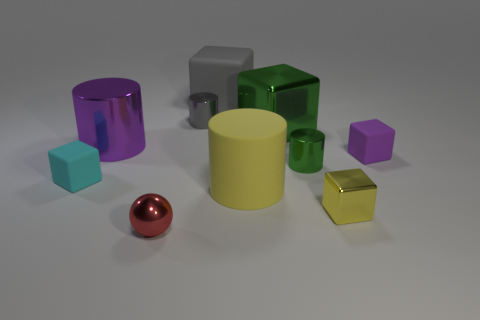Subtract all tiny green metal cylinders. How many cylinders are left? 3 Subtract all purple cubes. How many cubes are left? 4 Subtract all spheres. How many objects are left? 9 Subtract 1 spheres. How many spheres are left? 0 Subtract all yellow cubes. Subtract all green spheres. How many cubes are left? 4 Subtract all gray cubes. Subtract all small purple cubes. How many objects are left? 8 Add 8 green metallic cylinders. How many green metallic cylinders are left? 9 Add 8 big red rubber cylinders. How many big red rubber cylinders exist? 8 Subtract 1 purple cubes. How many objects are left? 9 